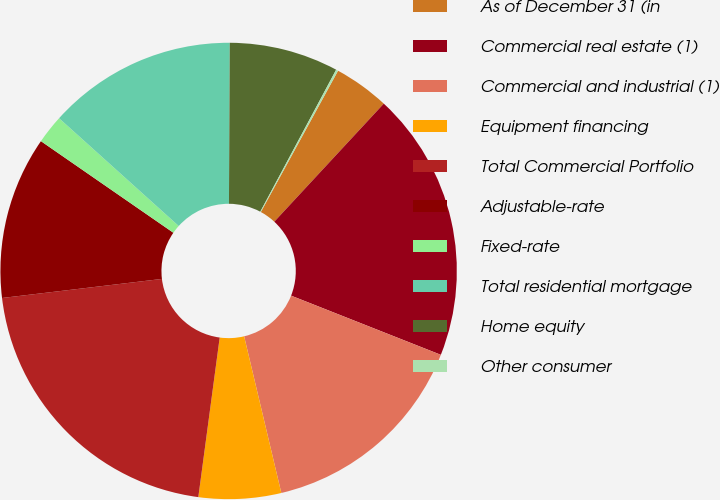Convert chart to OTSL. <chart><loc_0><loc_0><loc_500><loc_500><pie_chart><fcel>As of December 31 (in<fcel>Commercial real estate (1)<fcel>Commercial and industrial (1)<fcel>Equipment financing<fcel>Total Commercial Portfolio<fcel>Adjustable-rate<fcel>Fixed-rate<fcel>Total residential mortgage<fcel>Home equity<fcel>Other consumer<nl><fcel>3.94%<fcel>19.09%<fcel>15.3%<fcel>5.83%<fcel>20.99%<fcel>11.52%<fcel>2.04%<fcel>13.41%<fcel>7.73%<fcel>0.15%<nl></chart> 